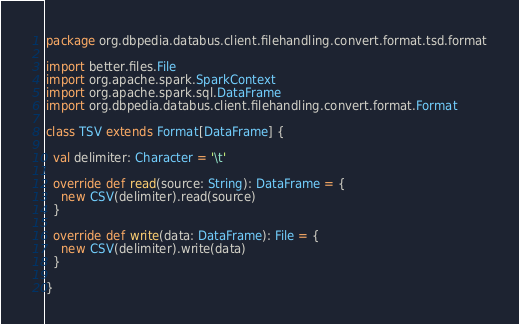<code> <loc_0><loc_0><loc_500><loc_500><_Scala_>package org.dbpedia.databus.client.filehandling.convert.format.tsd.format

import better.files.File
import org.apache.spark.SparkContext
import org.apache.spark.sql.DataFrame
import org.dbpedia.databus.client.filehandling.convert.format.Format

class TSV extends Format[DataFrame] {

  val delimiter: Character = '\t'

  override def read(source: String): DataFrame = {
    new CSV(delimiter).read(source)
  }

  override def write(data: DataFrame): File = {
    new CSV(delimiter).write(data)
  }

}
</code> 